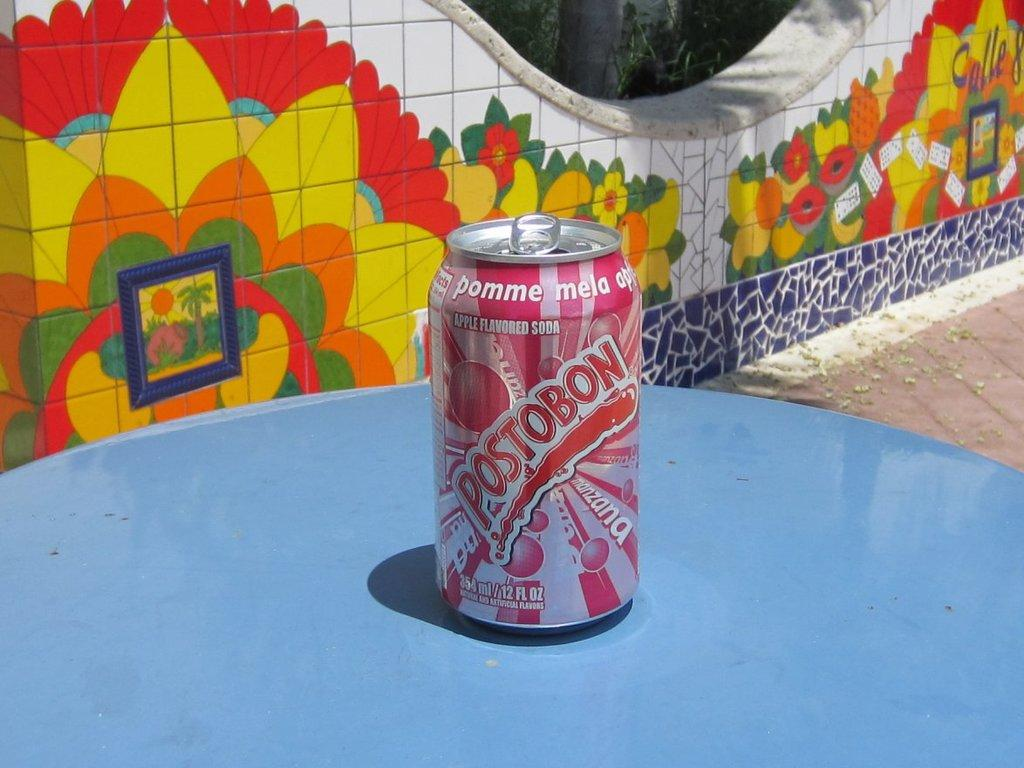<image>
Render a clear and concise summary of the photo. A Postobon can is sitting on a blue table 